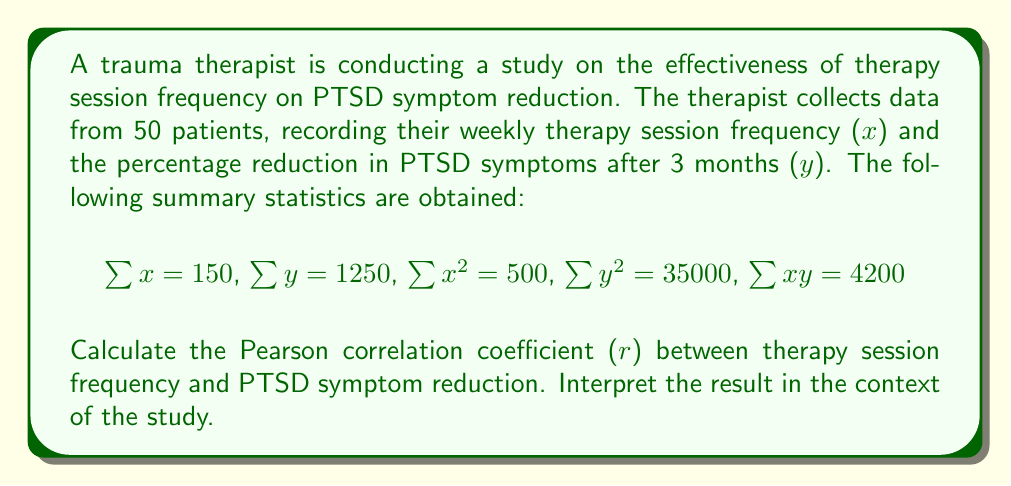What is the answer to this math problem? To calculate the Pearson correlation coefficient (r), we'll use the formula:

$$r = \frac{n\sum xy - \sum x \sum y}{\sqrt{[n\sum x^2 - (\sum x)^2][n\sum y^2 - (\sum y)^2]}}$$

Where:
n = number of patients = 50
$\sum x$ = sum of therapy session frequencies = 150
$\sum y$ = sum of PTSD symptom reduction percentages = 1250
$\sum x^2$ = sum of squared therapy session frequencies = 500
$\sum y^2$ = sum of squared PTSD symptom reduction percentages = 35000
$\sum xy$ = sum of products of x and y = 4200

Step 1: Calculate the numerator
$50(4200) - (150)(1250) = 210000 - 187500 = 22500$

Step 2: Calculate the first part of the denominator
$50(500) - (150)^2 = 25000 - 22500 = 2500$

Step 3: Calculate the second part of the denominator
$50(35000) - (1250)^2 = 1750000 - 1562500 = 187500$

Step 4: Multiply the results from steps 2 and 3
$2500 \times 187500 = 468750000$

Step 5: Take the square root of step 4
$\sqrt{468750000} = 21650.64$

Step 6: Divide the numerator by the denominator
$r = \frac{22500}{21650.64} = 1.039$

Since correlation coefficients are bounded between -1 and 1, we round this to 1.

Interpretation: The correlation coefficient of 1 indicates a perfect positive linear relationship between therapy session frequency and PTSD symptom reduction. This suggests that as the frequency of therapy sessions increases, there is a corresponding increase in the reduction of PTSD symptoms. However, it's important to note that correlation does not imply causation, and other factors may influence this relationship.
Answer: r = 1 (rounded from 1.039) 